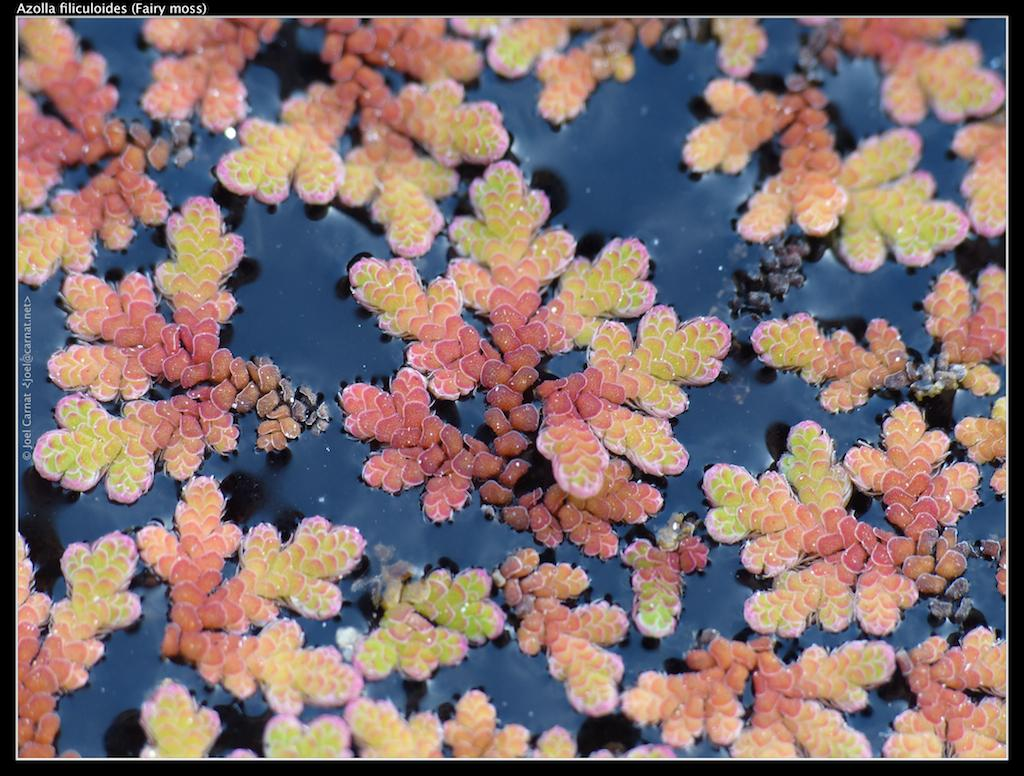What type of living organisms can be seen in the image? There are flowers in the image. What colors are the flowers? The flowers are green, orange, and pink in color. Where are the flowers located in the image? The flowers are on the surface of the water. What type of cap is the turkey wearing in the image? There is no turkey or cap present in the image; it features flowers on the surface of the water. 